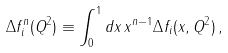Convert formula to latex. <formula><loc_0><loc_0><loc_500><loc_500>\Delta f _ { i } ^ { n } ( Q ^ { 2 } ) \equiv \int _ { 0 } ^ { 1 } d x \, x ^ { n - 1 } \Delta f _ { i } ( x , Q ^ { 2 } ) \, ,</formula> 